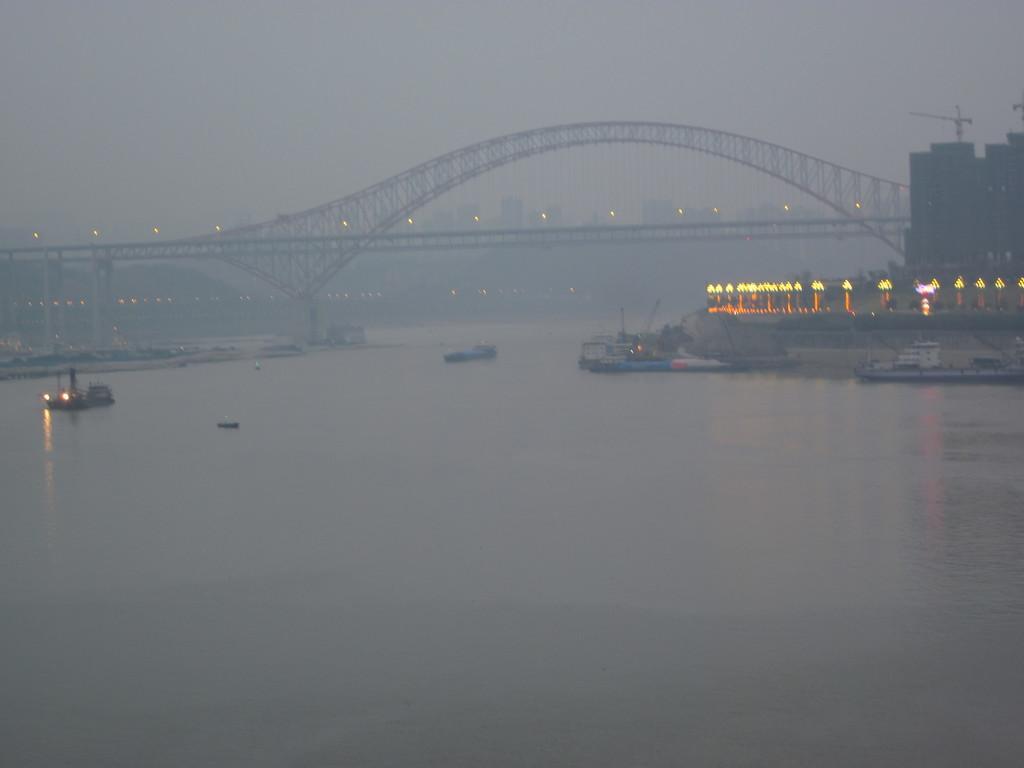In one or two sentences, can you explain what this image depicts? In this picture I can see the water in front, on which there are few boats. On the right side of this picture I see the lights. In the background I see a bridge, few more lights and I see the buildings. 